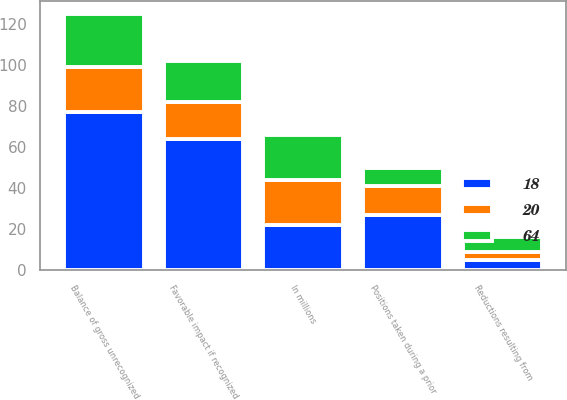<chart> <loc_0><loc_0><loc_500><loc_500><stacked_bar_chart><ecel><fcel>In millions<fcel>Balance of gross unrecognized<fcel>Positions taken during a prior<fcel>Reductions resulting from<fcel>Favorable impact if recognized<nl><fcel>20<fcel>22<fcel>22<fcel>14<fcel>4<fcel>18<nl><fcel>64<fcel>22<fcel>26<fcel>9<fcel>7<fcel>20<nl><fcel>18<fcel>22<fcel>77<fcel>27<fcel>5<fcel>64<nl></chart> 